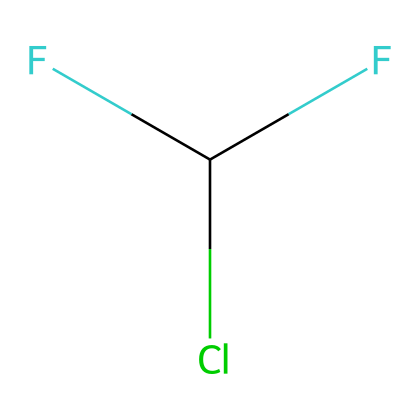What is the molecular formula of R-22? The chemical is represented as FC(F)Cl, where F stands for fluorine, C stands for carbon, and Cl stands for chlorine. Counting the atoms yields two fluorine atoms, one carbon atom, and one chlorine atom, leading to the formula C1H1Cl1F2.
Answer: C1H1Cl1F2 How many total valence electrons are in R-22? To determine the total valence electrons, count the valence electrons for each atom: Carbon has 4, Hydrogen has 1, Chlorine has 7, and Fluorine has 7. Therefore, total valence electrons = 4 (C) + 1 (H) + 7 (Cl) + 2*7 (F) = 4 + 1 + 7 + 14 = 26.
Answer: 26 What type of bonds are present in R-22? The SMILES representation indicates one single bond between carbon and chlorine, two single bonds between carbon and fluorine, and one single bond between carbon and hydrogen, which means they are all single covalent bonds.
Answer: single covalent bonds How many hydrogen atoms are in the molecule of R-22? By analyzing the SMILES, there is one hydrogen atom attached to the carbon atom in R-22.
Answer: 1 Is R-22 a saturated or unsaturated refrigerant? All carbon-carbon bonds in R-22 are single bonds, indicating that it has the maximum number of hydrogen atoms for its carbon content, categorizing it as saturated.
Answer: saturated What functional group is present in R-22? The presence of chlorine and fluorine in the structure signifies that R-22 is a haloalkane, which is characterized by the substitution of halogens (like Cl and F) on a carbon atom.
Answer: haloalkane 